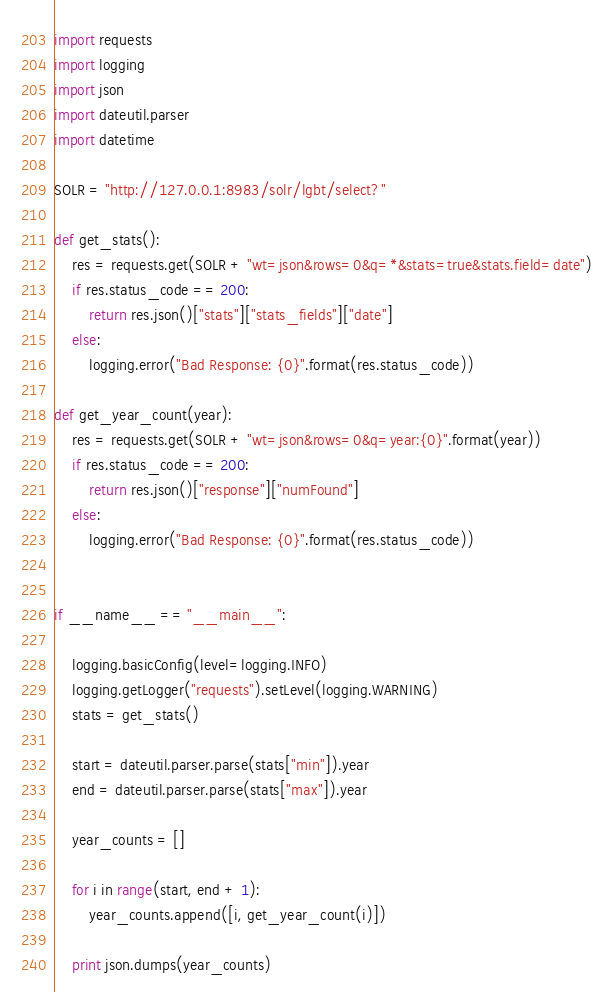<code> <loc_0><loc_0><loc_500><loc_500><_Python_>import requests
import logging
import json
import dateutil.parser
import datetime

SOLR = "http://127.0.0.1:8983/solr/lgbt/select?"

def get_stats():
    res = requests.get(SOLR + "wt=json&rows=0&q=*&stats=true&stats.field=date")
    if res.status_code == 200:
        return res.json()["stats"]["stats_fields"]["date"]
    else:
        logging.error("Bad Response: {0}".format(res.status_code))

def get_year_count(year):
    res = requests.get(SOLR + "wt=json&rows=0&q=year:{0}".format(year))
    if res.status_code == 200:
        return res.json()["response"]["numFound"]
    else:
        logging.error("Bad Response: {0}".format(res.status_code))


if __name__ == "__main__":

    logging.basicConfig(level=logging.INFO)
    logging.getLogger("requests").setLevel(logging.WARNING)
    stats = get_stats()
    
    start = dateutil.parser.parse(stats["min"]).year
    end = dateutil.parser.parse(stats["max"]).year
    
    year_counts = []
   
    for i in range(start, end + 1):
        year_counts.append([i, get_year_count(i)])

    print json.dumps(year_counts)

</code> 